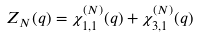<formula> <loc_0><loc_0><loc_500><loc_500>Z _ { N } ( q ) = \chi ^ { ( N ) } _ { 1 , 1 } ( q ) + \chi ^ { ( N ) } _ { 3 , 1 } ( q )</formula> 